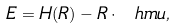Convert formula to latex. <formula><loc_0><loc_0><loc_500><loc_500>E = H ( R ) - R \cdot \ h m u ,</formula> 